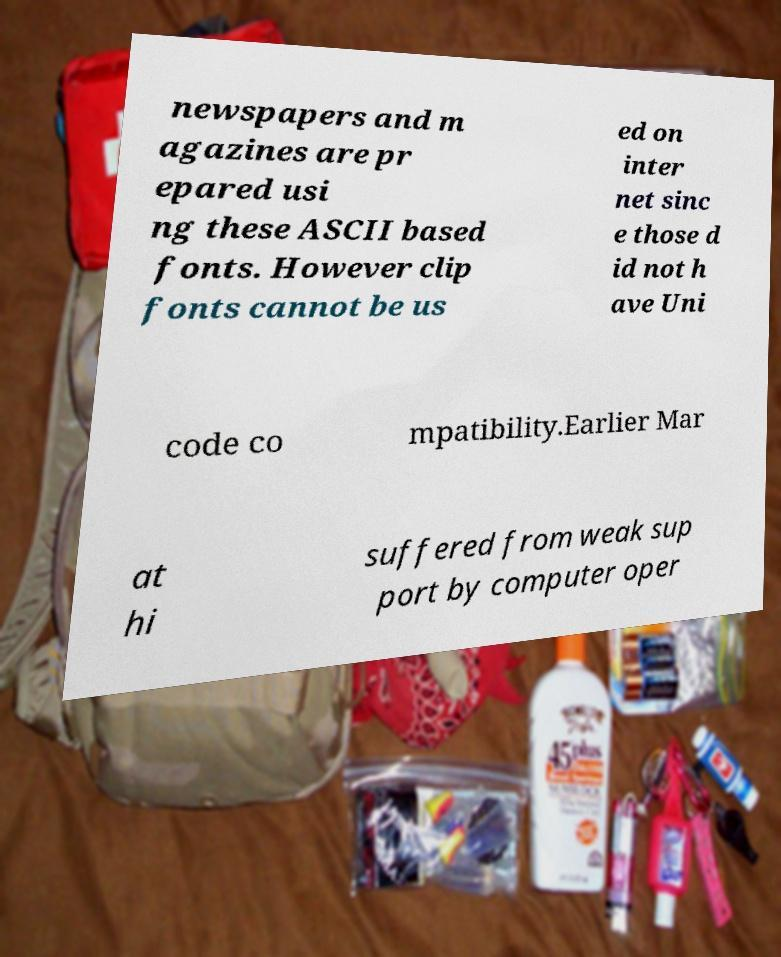I need the written content from this picture converted into text. Can you do that? newspapers and m agazines are pr epared usi ng these ASCII based fonts. However clip fonts cannot be us ed on inter net sinc e those d id not h ave Uni code co mpatibility.Earlier Mar at hi suffered from weak sup port by computer oper 